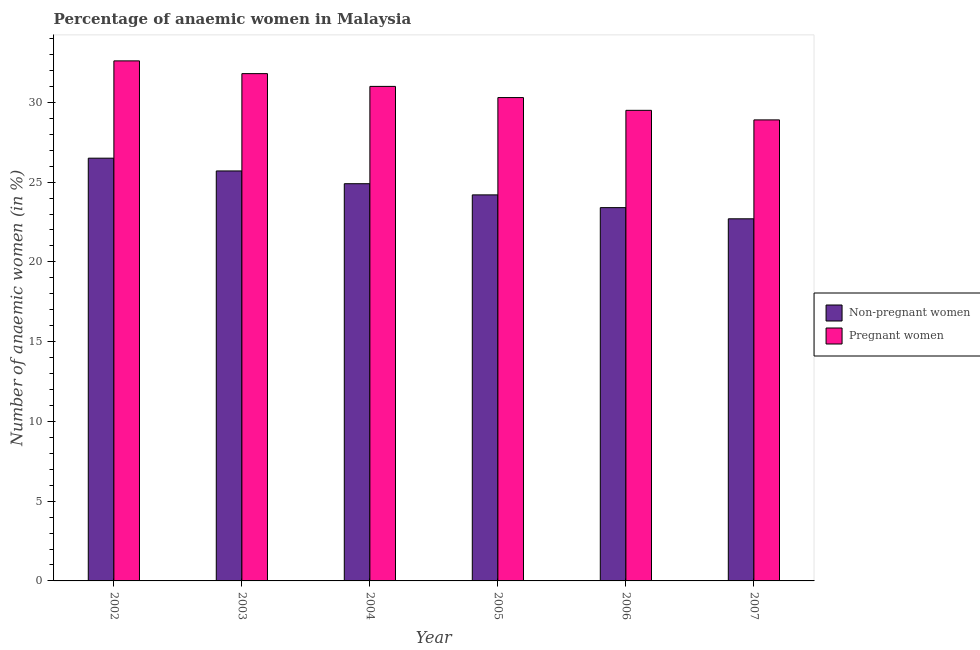How many different coloured bars are there?
Provide a succinct answer. 2. How many groups of bars are there?
Make the answer very short. 6. Are the number of bars on each tick of the X-axis equal?
Make the answer very short. Yes. In how many cases, is the number of bars for a given year not equal to the number of legend labels?
Your answer should be very brief. 0. What is the percentage of non-pregnant anaemic women in 2003?
Make the answer very short. 25.7. Across all years, what is the maximum percentage of pregnant anaemic women?
Your response must be concise. 32.6. Across all years, what is the minimum percentage of non-pregnant anaemic women?
Give a very brief answer. 22.7. What is the total percentage of non-pregnant anaemic women in the graph?
Offer a very short reply. 147.4. What is the difference between the percentage of pregnant anaemic women in 2006 and the percentage of non-pregnant anaemic women in 2002?
Your answer should be compact. -3.1. What is the average percentage of pregnant anaemic women per year?
Make the answer very short. 30.68. What is the ratio of the percentage of non-pregnant anaemic women in 2002 to that in 2004?
Provide a short and direct response. 1.06. Is the percentage of non-pregnant anaemic women in 2002 less than that in 2007?
Offer a very short reply. No. Is the difference between the percentage of pregnant anaemic women in 2004 and 2007 greater than the difference between the percentage of non-pregnant anaemic women in 2004 and 2007?
Your response must be concise. No. What is the difference between the highest and the second highest percentage of non-pregnant anaemic women?
Provide a short and direct response. 0.8. What is the difference between the highest and the lowest percentage of pregnant anaemic women?
Keep it short and to the point. 3.7. In how many years, is the percentage of pregnant anaemic women greater than the average percentage of pregnant anaemic women taken over all years?
Offer a very short reply. 3. What does the 1st bar from the left in 2006 represents?
Provide a short and direct response. Non-pregnant women. What does the 2nd bar from the right in 2007 represents?
Provide a succinct answer. Non-pregnant women. How many bars are there?
Ensure brevity in your answer.  12. Are all the bars in the graph horizontal?
Make the answer very short. No. How many years are there in the graph?
Provide a short and direct response. 6. What is the difference between two consecutive major ticks on the Y-axis?
Provide a short and direct response. 5. Where does the legend appear in the graph?
Your response must be concise. Center right. How are the legend labels stacked?
Your answer should be very brief. Vertical. What is the title of the graph?
Provide a succinct answer. Percentage of anaemic women in Malaysia. Does "Grants" appear as one of the legend labels in the graph?
Your answer should be very brief. No. What is the label or title of the X-axis?
Ensure brevity in your answer.  Year. What is the label or title of the Y-axis?
Give a very brief answer. Number of anaemic women (in %). What is the Number of anaemic women (in %) of Non-pregnant women in 2002?
Provide a succinct answer. 26.5. What is the Number of anaemic women (in %) in Pregnant women in 2002?
Your response must be concise. 32.6. What is the Number of anaemic women (in %) of Non-pregnant women in 2003?
Ensure brevity in your answer.  25.7. What is the Number of anaemic women (in %) of Pregnant women in 2003?
Offer a terse response. 31.8. What is the Number of anaemic women (in %) in Non-pregnant women in 2004?
Your answer should be compact. 24.9. What is the Number of anaemic women (in %) of Non-pregnant women in 2005?
Provide a succinct answer. 24.2. What is the Number of anaemic women (in %) of Pregnant women in 2005?
Keep it short and to the point. 30.3. What is the Number of anaemic women (in %) of Non-pregnant women in 2006?
Your response must be concise. 23.4. What is the Number of anaemic women (in %) in Pregnant women in 2006?
Your response must be concise. 29.5. What is the Number of anaemic women (in %) of Non-pregnant women in 2007?
Ensure brevity in your answer.  22.7. What is the Number of anaemic women (in %) in Pregnant women in 2007?
Give a very brief answer. 28.9. Across all years, what is the maximum Number of anaemic women (in %) in Non-pregnant women?
Your response must be concise. 26.5. Across all years, what is the maximum Number of anaemic women (in %) in Pregnant women?
Give a very brief answer. 32.6. Across all years, what is the minimum Number of anaemic women (in %) in Non-pregnant women?
Provide a succinct answer. 22.7. Across all years, what is the minimum Number of anaemic women (in %) of Pregnant women?
Offer a terse response. 28.9. What is the total Number of anaemic women (in %) of Non-pregnant women in the graph?
Keep it short and to the point. 147.4. What is the total Number of anaemic women (in %) of Pregnant women in the graph?
Offer a terse response. 184.1. What is the difference between the Number of anaemic women (in %) in Non-pregnant women in 2002 and that in 2003?
Offer a terse response. 0.8. What is the difference between the Number of anaemic women (in %) in Pregnant women in 2002 and that in 2007?
Your answer should be very brief. 3.7. What is the difference between the Number of anaemic women (in %) in Non-pregnant women in 2003 and that in 2004?
Ensure brevity in your answer.  0.8. What is the difference between the Number of anaemic women (in %) in Non-pregnant women in 2003 and that in 2006?
Give a very brief answer. 2.3. What is the difference between the Number of anaemic women (in %) in Pregnant women in 2003 and that in 2006?
Ensure brevity in your answer.  2.3. What is the difference between the Number of anaemic women (in %) of Non-pregnant women in 2003 and that in 2007?
Provide a short and direct response. 3. What is the difference between the Number of anaemic women (in %) of Pregnant women in 2004 and that in 2005?
Ensure brevity in your answer.  0.7. What is the difference between the Number of anaemic women (in %) of Non-pregnant women in 2004 and that in 2007?
Offer a very short reply. 2.2. What is the difference between the Number of anaemic women (in %) in Pregnant women in 2005 and that in 2006?
Offer a very short reply. 0.8. What is the difference between the Number of anaemic women (in %) of Non-pregnant women in 2005 and that in 2007?
Offer a very short reply. 1.5. What is the difference between the Number of anaemic women (in %) of Pregnant women in 2006 and that in 2007?
Ensure brevity in your answer.  0.6. What is the difference between the Number of anaemic women (in %) of Non-pregnant women in 2002 and the Number of anaemic women (in %) of Pregnant women in 2004?
Give a very brief answer. -4.5. What is the difference between the Number of anaemic women (in %) of Non-pregnant women in 2002 and the Number of anaemic women (in %) of Pregnant women in 2006?
Your response must be concise. -3. What is the difference between the Number of anaemic women (in %) of Non-pregnant women in 2002 and the Number of anaemic women (in %) of Pregnant women in 2007?
Your answer should be very brief. -2.4. What is the difference between the Number of anaemic women (in %) in Non-pregnant women in 2003 and the Number of anaemic women (in %) in Pregnant women in 2004?
Give a very brief answer. -5.3. What is the difference between the Number of anaemic women (in %) of Non-pregnant women in 2003 and the Number of anaemic women (in %) of Pregnant women in 2006?
Your response must be concise. -3.8. What is the difference between the Number of anaemic women (in %) in Non-pregnant women in 2004 and the Number of anaemic women (in %) in Pregnant women in 2006?
Make the answer very short. -4.6. What is the difference between the Number of anaemic women (in %) of Non-pregnant women in 2005 and the Number of anaemic women (in %) of Pregnant women in 2006?
Your answer should be compact. -5.3. What is the difference between the Number of anaemic women (in %) in Non-pregnant women in 2005 and the Number of anaemic women (in %) in Pregnant women in 2007?
Your answer should be very brief. -4.7. What is the difference between the Number of anaemic women (in %) in Non-pregnant women in 2006 and the Number of anaemic women (in %) in Pregnant women in 2007?
Offer a very short reply. -5.5. What is the average Number of anaemic women (in %) in Non-pregnant women per year?
Offer a terse response. 24.57. What is the average Number of anaemic women (in %) of Pregnant women per year?
Your answer should be compact. 30.68. In the year 2004, what is the difference between the Number of anaemic women (in %) of Non-pregnant women and Number of anaemic women (in %) of Pregnant women?
Provide a short and direct response. -6.1. In the year 2006, what is the difference between the Number of anaemic women (in %) of Non-pregnant women and Number of anaemic women (in %) of Pregnant women?
Provide a succinct answer. -6.1. What is the ratio of the Number of anaemic women (in %) in Non-pregnant women in 2002 to that in 2003?
Provide a succinct answer. 1.03. What is the ratio of the Number of anaemic women (in %) of Pregnant women in 2002 to that in 2003?
Your answer should be very brief. 1.03. What is the ratio of the Number of anaemic women (in %) of Non-pregnant women in 2002 to that in 2004?
Ensure brevity in your answer.  1.06. What is the ratio of the Number of anaemic women (in %) of Pregnant women in 2002 to that in 2004?
Give a very brief answer. 1.05. What is the ratio of the Number of anaemic women (in %) of Non-pregnant women in 2002 to that in 2005?
Give a very brief answer. 1.09. What is the ratio of the Number of anaemic women (in %) of Pregnant women in 2002 to that in 2005?
Make the answer very short. 1.08. What is the ratio of the Number of anaemic women (in %) in Non-pregnant women in 2002 to that in 2006?
Give a very brief answer. 1.13. What is the ratio of the Number of anaemic women (in %) of Pregnant women in 2002 to that in 2006?
Provide a short and direct response. 1.11. What is the ratio of the Number of anaemic women (in %) of Non-pregnant women in 2002 to that in 2007?
Make the answer very short. 1.17. What is the ratio of the Number of anaemic women (in %) of Pregnant women in 2002 to that in 2007?
Provide a succinct answer. 1.13. What is the ratio of the Number of anaemic women (in %) in Non-pregnant women in 2003 to that in 2004?
Offer a terse response. 1.03. What is the ratio of the Number of anaemic women (in %) in Pregnant women in 2003 to that in 2004?
Give a very brief answer. 1.03. What is the ratio of the Number of anaemic women (in %) in Non-pregnant women in 2003 to that in 2005?
Ensure brevity in your answer.  1.06. What is the ratio of the Number of anaemic women (in %) of Pregnant women in 2003 to that in 2005?
Provide a short and direct response. 1.05. What is the ratio of the Number of anaemic women (in %) in Non-pregnant women in 2003 to that in 2006?
Provide a short and direct response. 1.1. What is the ratio of the Number of anaemic women (in %) in Pregnant women in 2003 to that in 2006?
Offer a terse response. 1.08. What is the ratio of the Number of anaemic women (in %) in Non-pregnant women in 2003 to that in 2007?
Provide a short and direct response. 1.13. What is the ratio of the Number of anaemic women (in %) of Pregnant women in 2003 to that in 2007?
Keep it short and to the point. 1.1. What is the ratio of the Number of anaemic women (in %) in Non-pregnant women in 2004 to that in 2005?
Provide a succinct answer. 1.03. What is the ratio of the Number of anaemic women (in %) of Pregnant women in 2004 to that in 2005?
Your response must be concise. 1.02. What is the ratio of the Number of anaemic women (in %) in Non-pregnant women in 2004 to that in 2006?
Your answer should be very brief. 1.06. What is the ratio of the Number of anaemic women (in %) in Pregnant women in 2004 to that in 2006?
Your answer should be compact. 1.05. What is the ratio of the Number of anaemic women (in %) of Non-pregnant women in 2004 to that in 2007?
Give a very brief answer. 1.1. What is the ratio of the Number of anaemic women (in %) of Pregnant women in 2004 to that in 2007?
Ensure brevity in your answer.  1.07. What is the ratio of the Number of anaemic women (in %) of Non-pregnant women in 2005 to that in 2006?
Make the answer very short. 1.03. What is the ratio of the Number of anaemic women (in %) of Pregnant women in 2005 to that in 2006?
Offer a terse response. 1.03. What is the ratio of the Number of anaemic women (in %) in Non-pregnant women in 2005 to that in 2007?
Make the answer very short. 1.07. What is the ratio of the Number of anaemic women (in %) in Pregnant women in 2005 to that in 2007?
Offer a very short reply. 1.05. What is the ratio of the Number of anaemic women (in %) in Non-pregnant women in 2006 to that in 2007?
Provide a succinct answer. 1.03. What is the ratio of the Number of anaemic women (in %) of Pregnant women in 2006 to that in 2007?
Your answer should be very brief. 1.02. What is the difference between the highest and the second highest Number of anaemic women (in %) of Pregnant women?
Your response must be concise. 0.8. What is the difference between the highest and the lowest Number of anaemic women (in %) of Non-pregnant women?
Ensure brevity in your answer.  3.8. 